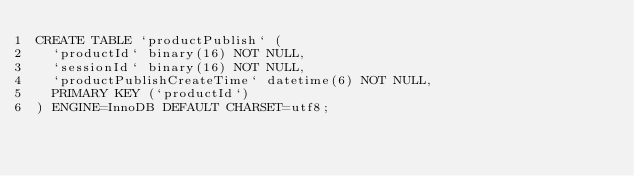<code> <loc_0><loc_0><loc_500><loc_500><_SQL_>CREATE TABLE `productPublish` (
  `productId` binary(16) NOT NULL,
  `sessionId` binary(16) NOT NULL,
  `productPublishCreateTime` datetime(6) NOT NULL,
  PRIMARY KEY (`productId`)
) ENGINE=InnoDB DEFAULT CHARSET=utf8;
</code> 